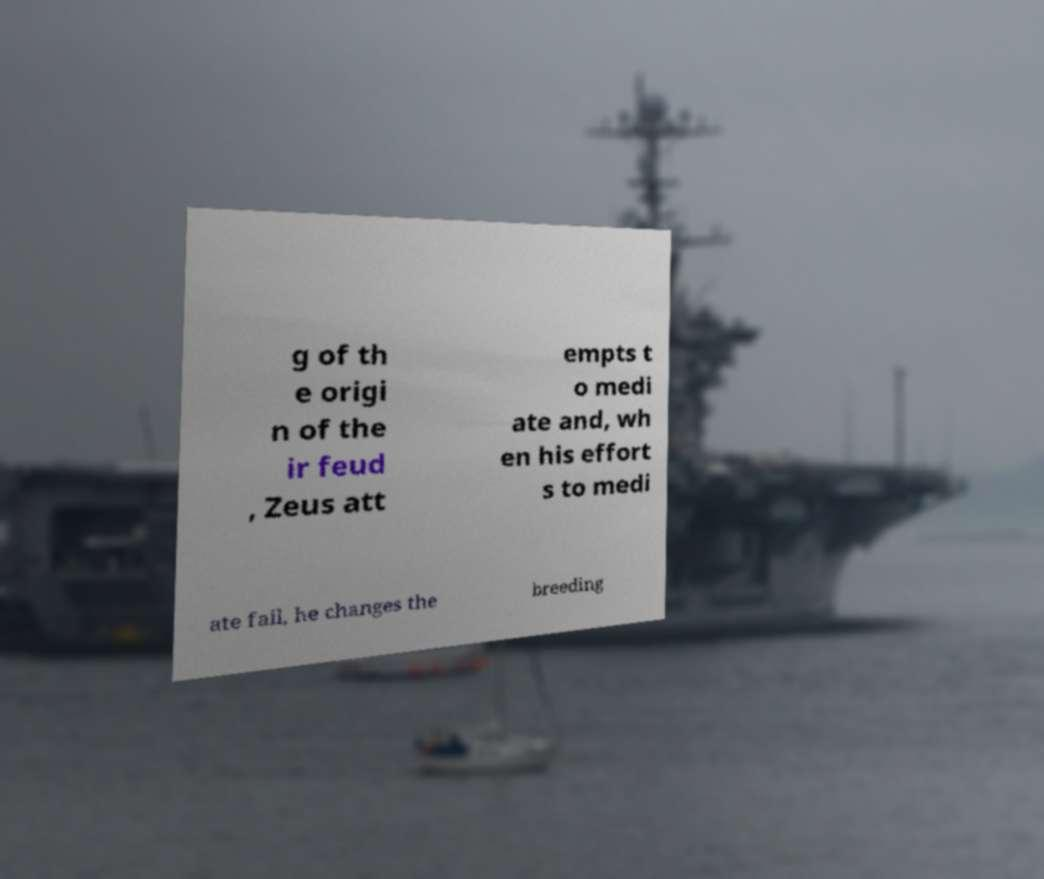Can you accurately transcribe the text from the provided image for me? g of th e origi n of the ir feud , Zeus att empts t o medi ate and, wh en his effort s to medi ate fail, he changes the breeding 